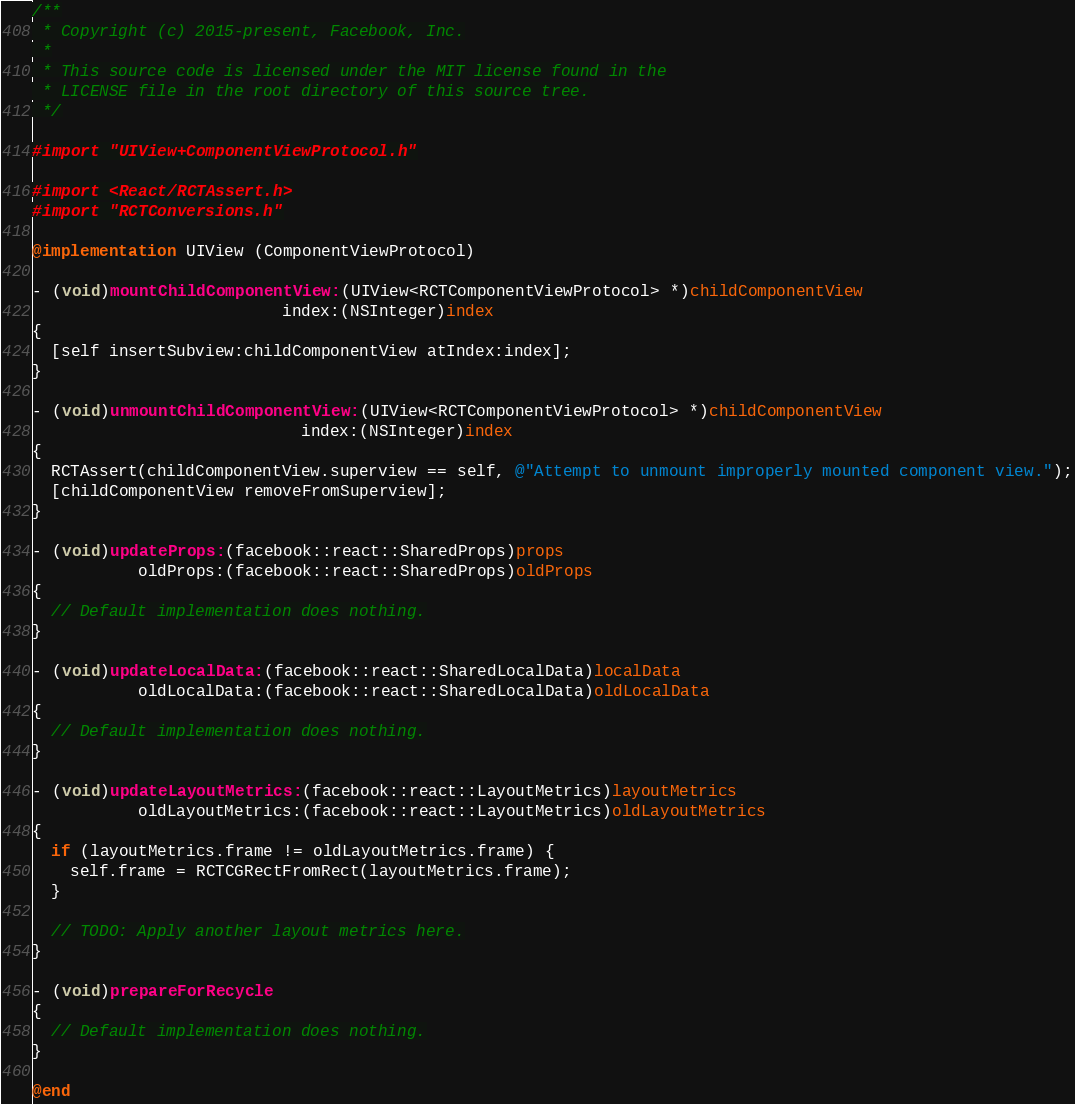Convert code to text. <code><loc_0><loc_0><loc_500><loc_500><_ObjectiveC_>/**
 * Copyright (c) 2015-present, Facebook, Inc.
 *
 * This source code is licensed under the MIT license found in the
 * LICENSE file in the root directory of this source tree.
 */

#import "UIView+ComponentViewProtocol.h"

#import <React/RCTAssert.h>
#import "RCTConversions.h"

@implementation UIView (ComponentViewProtocol)

- (void)mountChildComponentView:(UIView<RCTComponentViewProtocol> *)childComponentView
                          index:(NSInteger)index
{
  [self insertSubview:childComponentView atIndex:index];
}

- (void)unmountChildComponentView:(UIView<RCTComponentViewProtocol> *)childComponentView
                            index:(NSInteger)index
{
  RCTAssert(childComponentView.superview == self, @"Attempt to unmount improperly mounted component view.");
  [childComponentView removeFromSuperview];
}

- (void)updateProps:(facebook::react::SharedProps)props
           oldProps:(facebook::react::SharedProps)oldProps
{
  // Default implementation does nothing.
}

- (void)updateLocalData:(facebook::react::SharedLocalData)localData
           oldLocalData:(facebook::react::SharedLocalData)oldLocalData
{
  // Default implementation does nothing.
}

- (void)updateLayoutMetrics:(facebook::react::LayoutMetrics)layoutMetrics
           oldLayoutMetrics:(facebook::react::LayoutMetrics)oldLayoutMetrics
{
  if (layoutMetrics.frame != oldLayoutMetrics.frame) {
    self.frame = RCTCGRectFromRect(layoutMetrics.frame);
  }

  // TODO: Apply another layout metrics here.
}

- (void)prepareForRecycle
{
  // Default implementation does nothing.
}

@end
</code> 